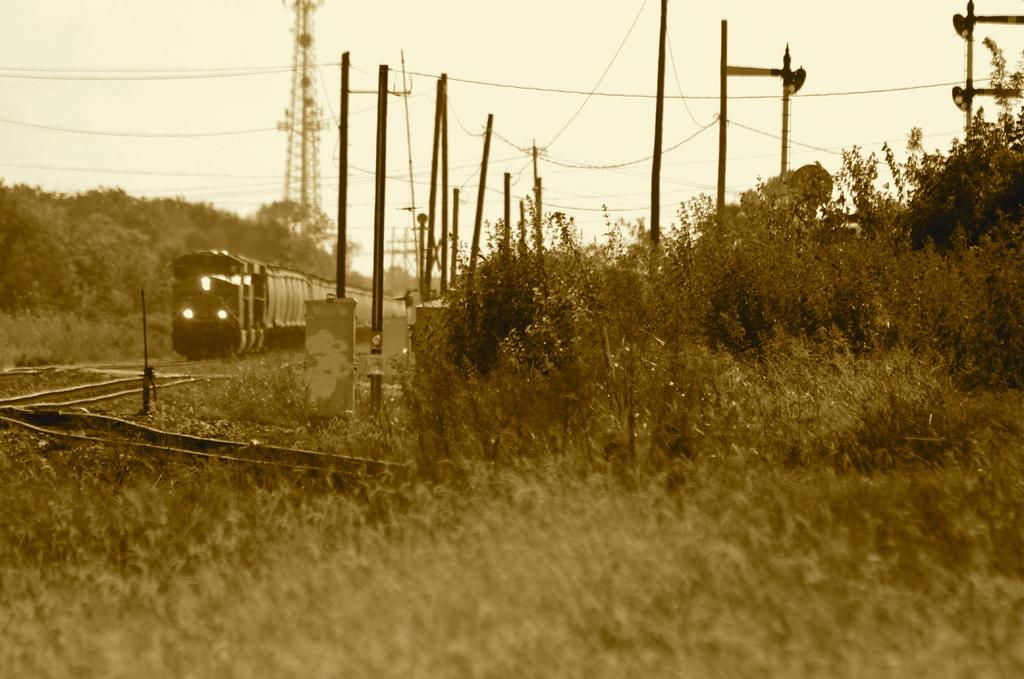What is the main subject of the image? The main subject of the image is a train. Where is the train located in the image? The train is on a railway track. What else can be seen in the image besides the train? There are poles, cables, a tower, plants, trees, and the sky visible in the image. What type of disgust can be seen on the train's face in the image? There is no face or expression of disgust on the train in the image, as it is a vehicle and not a living being. 